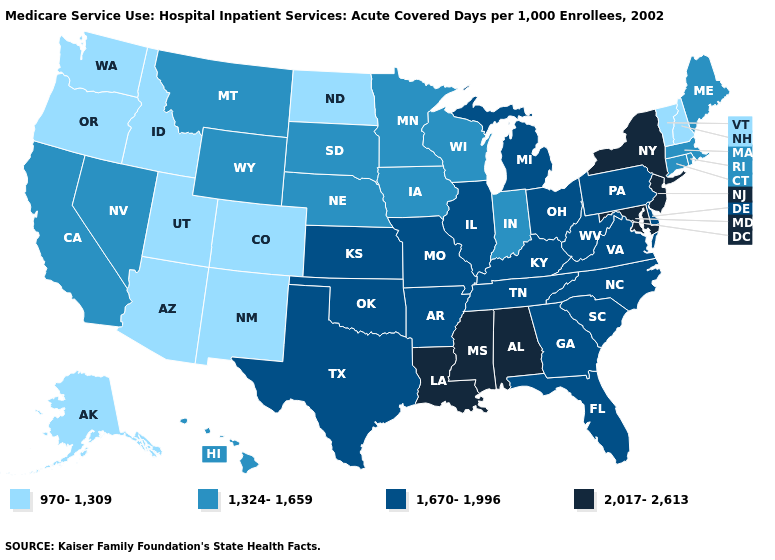Name the states that have a value in the range 970-1,309?
Short answer required. Alaska, Arizona, Colorado, Idaho, New Hampshire, New Mexico, North Dakota, Oregon, Utah, Vermont, Washington. Name the states that have a value in the range 2,017-2,613?
Give a very brief answer. Alabama, Louisiana, Maryland, Mississippi, New Jersey, New York. What is the value of Iowa?
Keep it brief. 1,324-1,659. Does the first symbol in the legend represent the smallest category?
Quick response, please. Yes. What is the value of Maryland?
Give a very brief answer. 2,017-2,613. What is the lowest value in states that border Mississippi?
Answer briefly. 1,670-1,996. Does North Dakota have the lowest value in the MidWest?
Be succinct. Yes. Does the map have missing data?
Write a very short answer. No. What is the lowest value in states that border Virginia?
Write a very short answer. 1,670-1,996. What is the highest value in the West ?
Be succinct. 1,324-1,659. Name the states that have a value in the range 1,324-1,659?
Short answer required. California, Connecticut, Hawaii, Indiana, Iowa, Maine, Massachusetts, Minnesota, Montana, Nebraska, Nevada, Rhode Island, South Dakota, Wisconsin, Wyoming. Does Rhode Island have the same value as Iowa?
Give a very brief answer. Yes. What is the value of Vermont?
Short answer required. 970-1,309. Does New Mexico have the same value as Nebraska?
Concise answer only. No. 